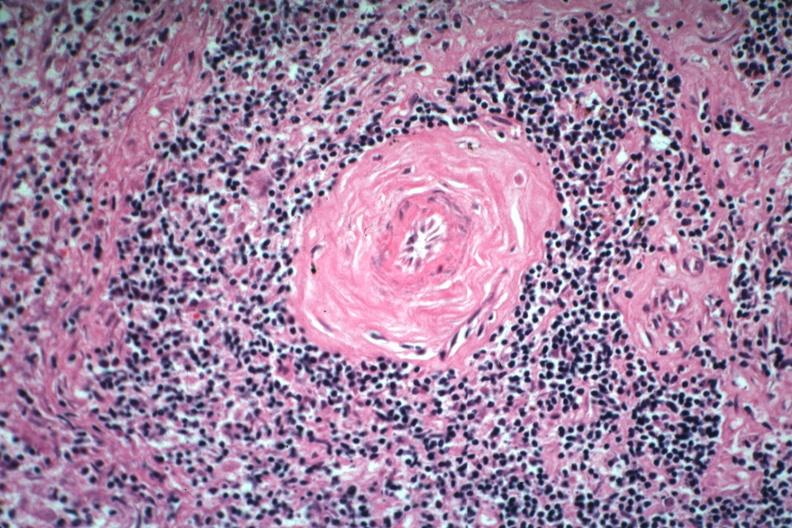what is present?
Answer the question using a single word or phrase. Lupus erythematosus periarterial fibrosis 